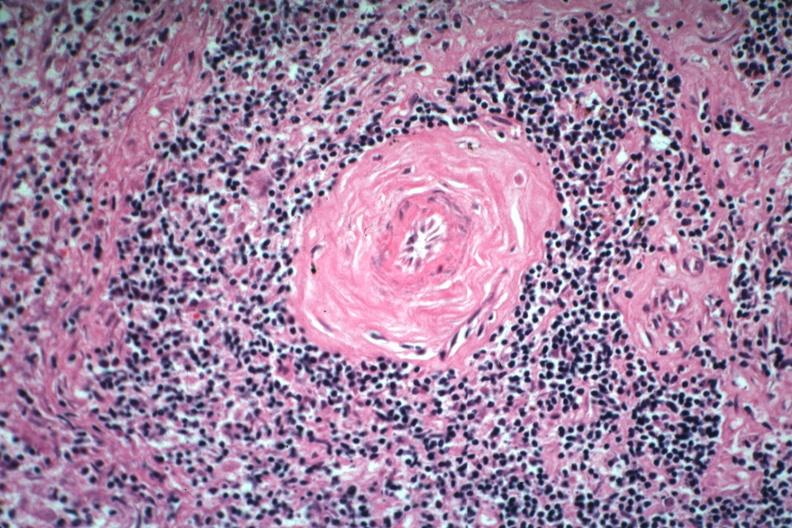what is present?
Answer the question using a single word or phrase. Lupus erythematosus periarterial fibrosis 